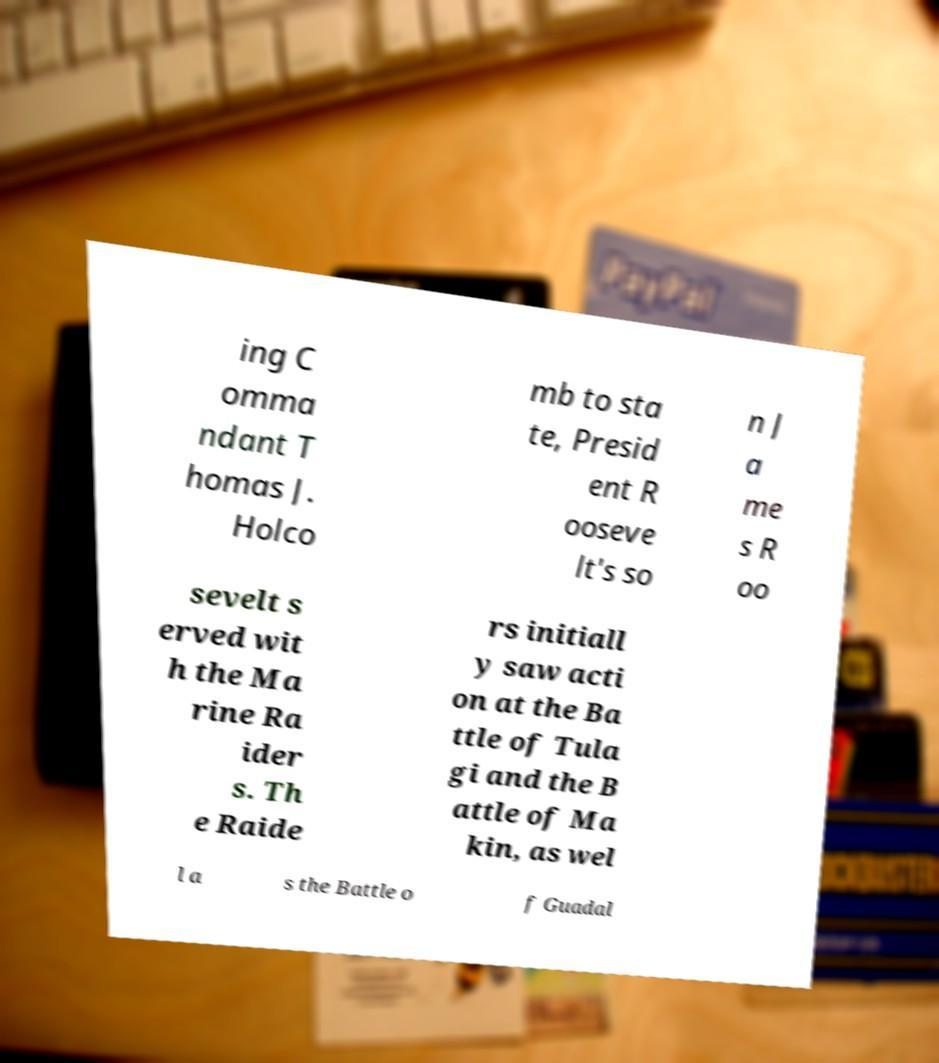I need the written content from this picture converted into text. Can you do that? ing C omma ndant T homas J. Holco mb to sta te, Presid ent R ooseve lt's so n J a me s R oo sevelt s erved wit h the Ma rine Ra ider s. Th e Raide rs initiall y saw acti on at the Ba ttle of Tula gi and the B attle of Ma kin, as wel l a s the Battle o f Guadal 